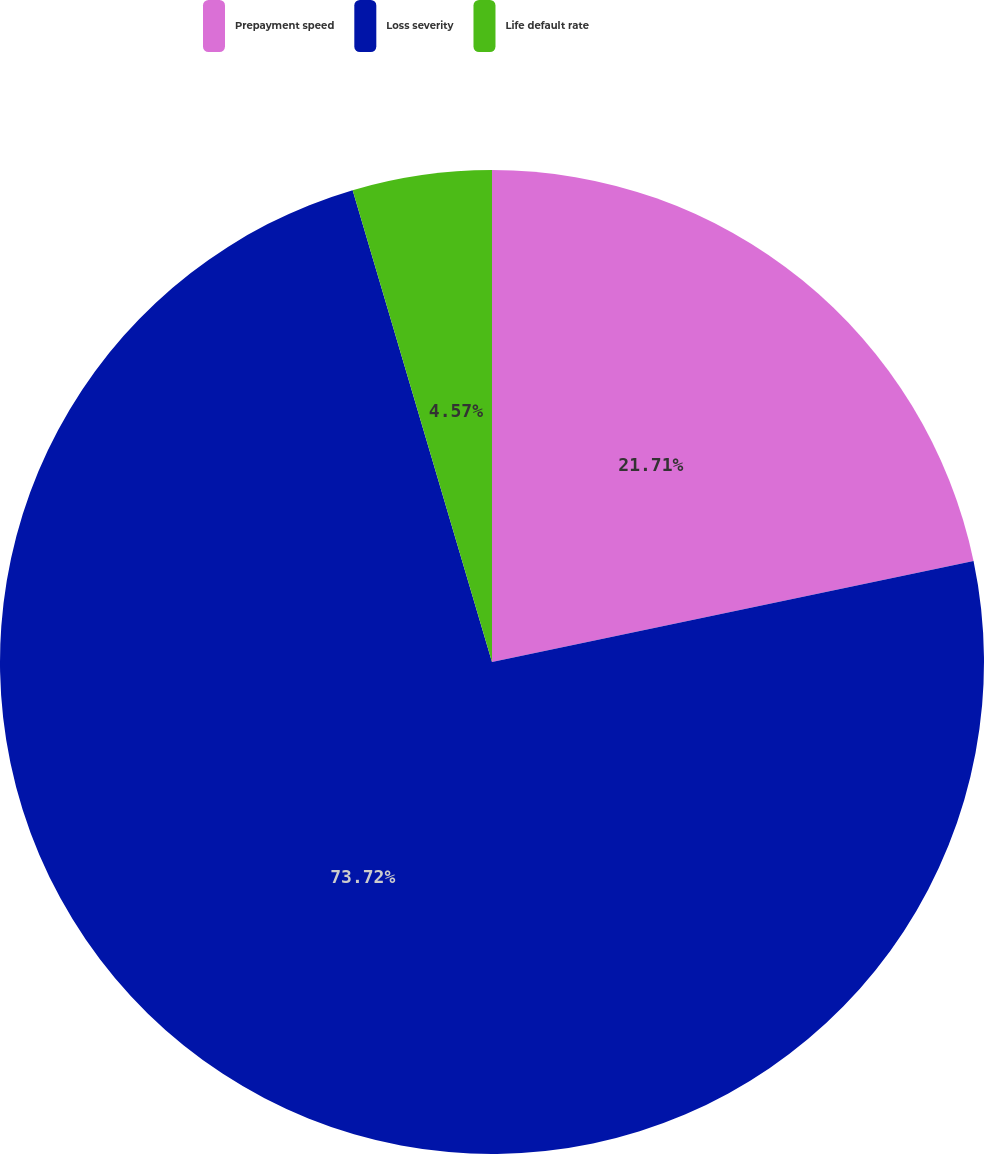Convert chart. <chart><loc_0><loc_0><loc_500><loc_500><pie_chart><fcel>Prepayment speed<fcel>Loss severity<fcel>Life default rate<nl><fcel>21.71%<fcel>73.71%<fcel>4.57%<nl></chart> 